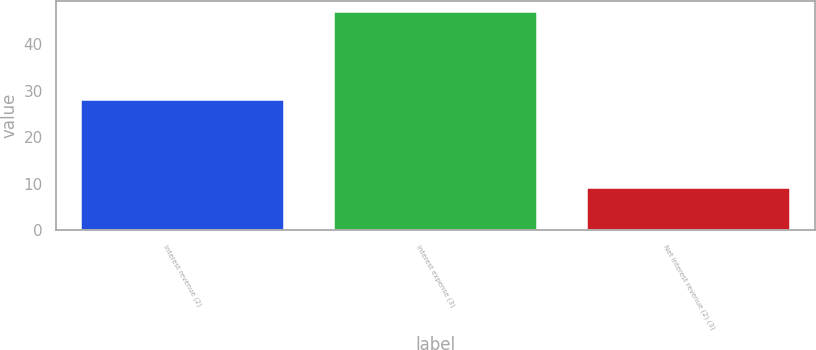Convert chart. <chart><loc_0><loc_0><loc_500><loc_500><bar_chart><fcel>Interest revenue (2)<fcel>Interest expense (3)<fcel>Net interest revenue (2) (3)<nl><fcel>28<fcel>47<fcel>9<nl></chart> 